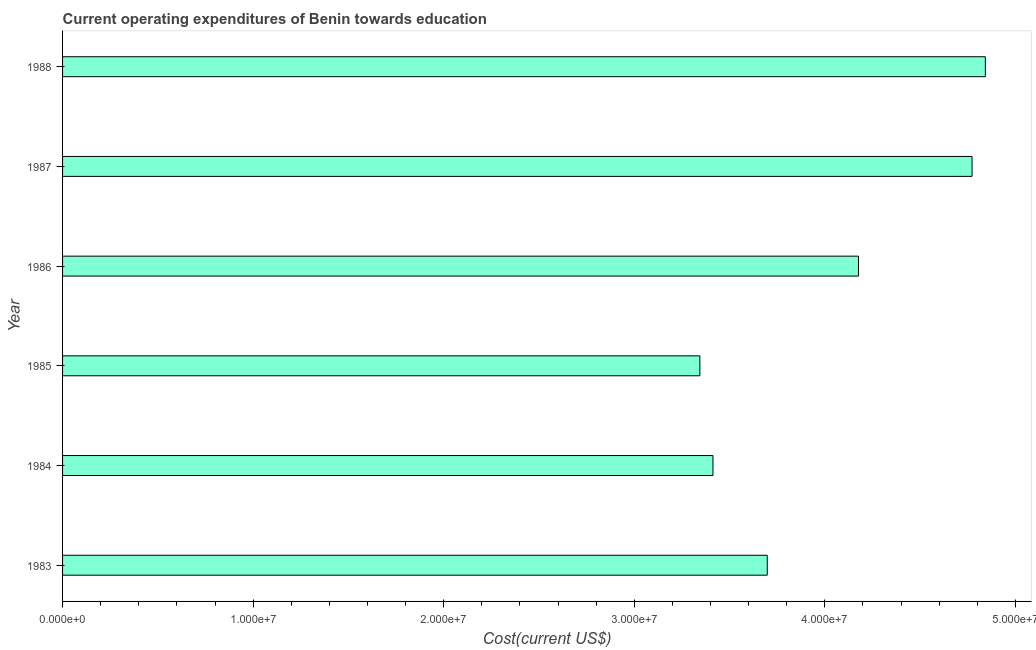Does the graph contain any zero values?
Your response must be concise. No. Does the graph contain grids?
Provide a short and direct response. No. What is the title of the graph?
Offer a very short reply. Current operating expenditures of Benin towards education. What is the label or title of the X-axis?
Offer a terse response. Cost(current US$). What is the label or title of the Y-axis?
Give a very brief answer. Year. What is the education expenditure in 1988?
Your answer should be very brief. 4.84e+07. Across all years, what is the maximum education expenditure?
Your response must be concise. 4.84e+07. Across all years, what is the minimum education expenditure?
Your answer should be compact. 3.34e+07. In which year was the education expenditure maximum?
Keep it short and to the point. 1988. In which year was the education expenditure minimum?
Ensure brevity in your answer.  1985. What is the sum of the education expenditure?
Your answer should be very brief. 2.42e+08. What is the difference between the education expenditure in 1983 and 1986?
Offer a very short reply. -4.79e+06. What is the average education expenditure per year?
Ensure brevity in your answer.  4.04e+07. What is the median education expenditure?
Give a very brief answer. 3.94e+07. Do a majority of the years between 1985 and 1988 (inclusive) have education expenditure greater than 32000000 US$?
Give a very brief answer. Yes. What is the difference between the highest and the second highest education expenditure?
Provide a short and direct response. 6.98e+05. What is the difference between the highest and the lowest education expenditure?
Your response must be concise. 1.50e+07. Are the values on the major ticks of X-axis written in scientific E-notation?
Your answer should be compact. Yes. What is the Cost(current US$) in 1983?
Your response must be concise. 3.70e+07. What is the Cost(current US$) in 1984?
Provide a succinct answer. 3.41e+07. What is the Cost(current US$) of 1985?
Offer a very short reply. 3.34e+07. What is the Cost(current US$) in 1986?
Provide a short and direct response. 4.18e+07. What is the Cost(current US$) in 1987?
Keep it short and to the point. 4.77e+07. What is the Cost(current US$) in 1988?
Keep it short and to the point. 4.84e+07. What is the difference between the Cost(current US$) in 1983 and 1984?
Your answer should be compact. 2.85e+06. What is the difference between the Cost(current US$) in 1983 and 1985?
Your response must be concise. 3.54e+06. What is the difference between the Cost(current US$) in 1983 and 1986?
Your answer should be compact. -4.79e+06. What is the difference between the Cost(current US$) in 1983 and 1987?
Ensure brevity in your answer.  -1.07e+07. What is the difference between the Cost(current US$) in 1983 and 1988?
Keep it short and to the point. -1.14e+07. What is the difference between the Cost(current US$) in 1984 and 1985?
Give a very brief answer. 6.87e+05. What is the difference between the Cost(current US$) in 1984 and 1986?
Provide a short and direct response. -7.64e+06. What is the difference between the Cost(current US$) in 1984 and 1987?
Ensure brevity in your answer.  -1.36e+07. What is the difference between the Cost(current US$) in 1984 and 1988?
Keep it short and to the point. -1.43e+07. What is the difference between the Cost(current US$) in 1985 and 1986?
Your answer should be compact. -8.33e+06. What is the difference between the Cost(current US$) in 1985 and 1987?
Make the answer very short. -1.43e+07. What is the difference between the Cost(current US$) in 1985 and 1988?
Your answer should be very brief. -1.50e+07. What is the difference between the Cost(current US$) in 1986 and 1987?
Your response must be concise. -5.96e+06. What is the difference between the Cost(current US$) in 1986 and 1988?
Ensure brevity in your answer.  -6.66e+06. What is the difference between the Cost(current US$) in 1987 and 1988?
Your answer should be very brief. -6.98e+05. What is the ratio of the Cost(current US$) in 1983 to that in 1984?
Provide a short and direct response. 1.08. What is the ratio of the Cost(current US$) in 1983 to that in 1985?
Offer a terse response. 1.11. What is the ratio of the Cost(current US$) in 1983 to that in 1986?
Give a very brief answer. 0.89. What is the ratio of the Cost(current US$) in 1983 to that in 1987?
Offer a very short reply. 0.78. What is the ratio of the Cost(current US$) in 1983 to that in 1988?
Keep it short and to the point. 0.76. What is the ratio of the Cost(current US$) in 1984 to that in 1985?
Ensure brevity in your answer.  1.02. What is the ratio of the Cost(current US$) in 1984 to that in 1986?
Your answer should be very brief. 0.82. What is the ratio of the Cost(current US$) in 1984 to that in 1987?
Provide a succinct answer. 0.71. What is the ratio of the Cost(current US$) in 1984 to that in 1988?
Your answer should be compact. 0.7. What is the ratio of the Cost(current US$) in 1985 to that in 1986?
Your answer should be very brief. 0.8. What is the ratio of the Cost(current US$) in 1985 to that in 1987?
Your answer should be compact. 0.7. What is the ratio of the Cost(current US$) in 1985 to that in 1988?
Ensure brevity in your answer.  0.69. What is the ratio of the Cost(current US$) in 1986 to that in 1987?
Provide a succinct answer. 0.88. What is the ratio of the Cost(current US$) in 1986 to that in 1988?
Make the answer very short. 0.86. 